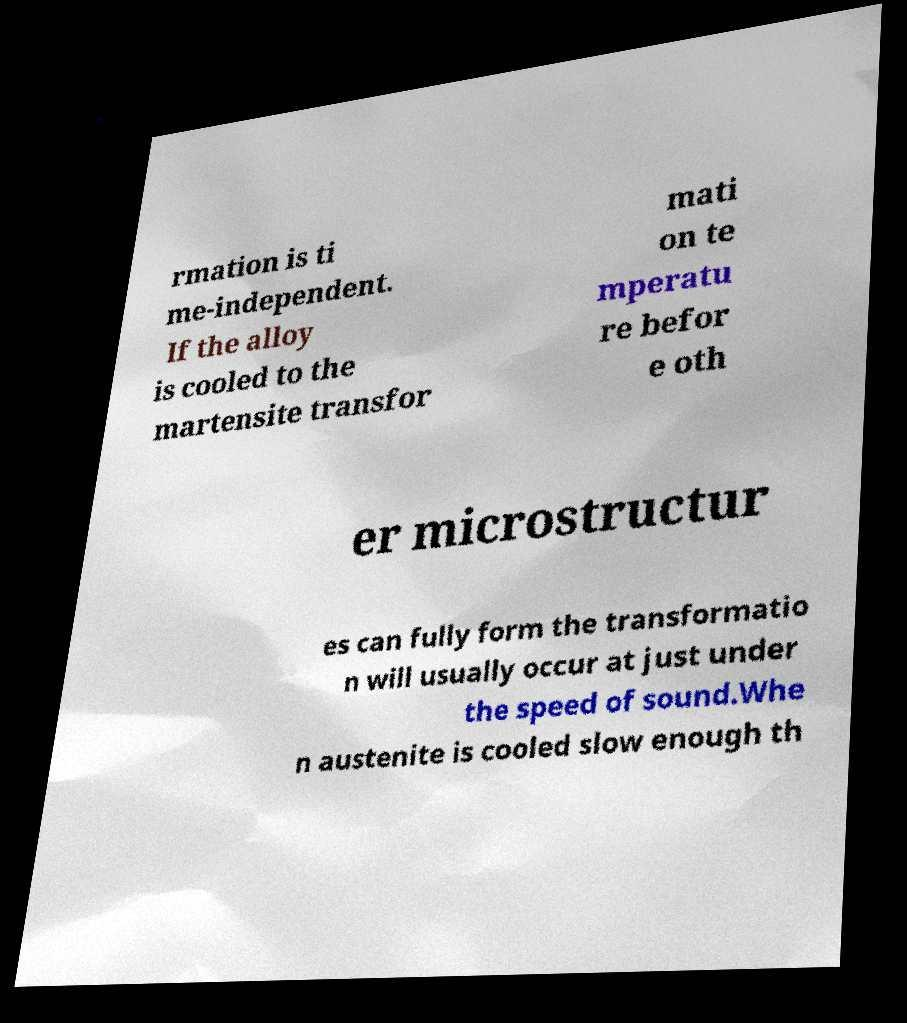Can you read and provide the text displayed in the image?This photo seems to have some interesting text. Can you extract and type it out for me? rmation is ti me-independent. If the alloy is cooled to the martensite transfor mati on te mperatu re befor e oth er microstructur es can fully form the transformatio n will usually occur at just under the speed of sound.Whe n austenite is cooled slow enough th 